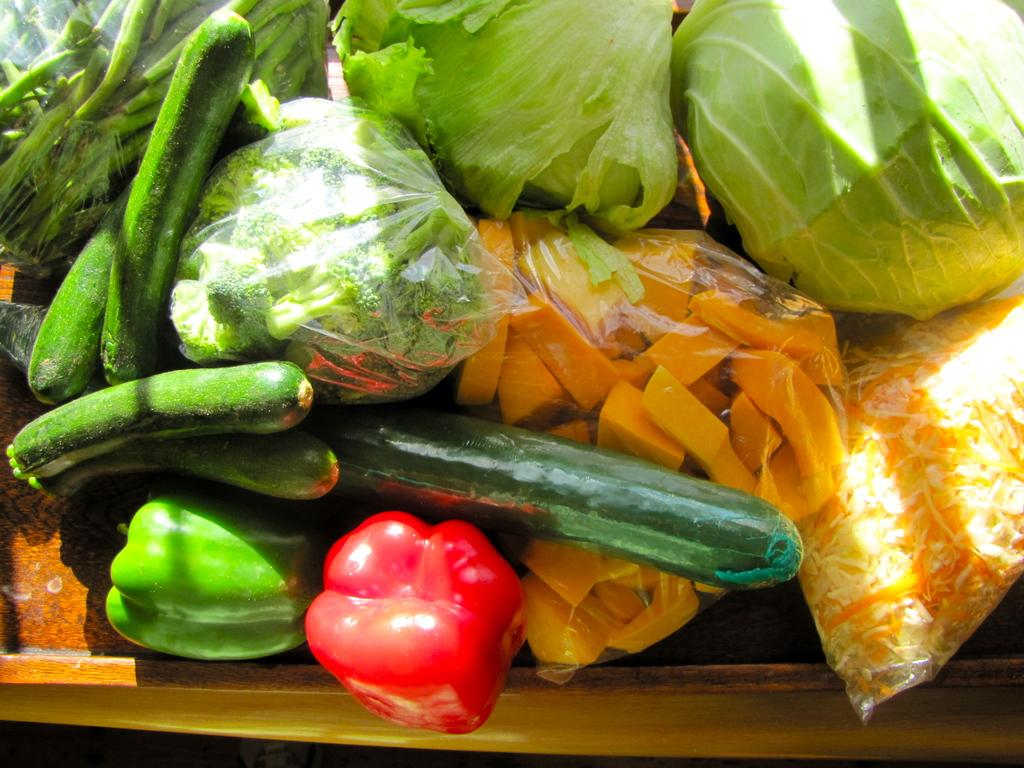What is located at the bottom of the image? There is a table at the bottom of the image. What is placed on the table? There are vegetables on the table. What type of quiver is being used during the meeting in the image? There is no meeting or quiver present in the image; it only features a table with vegetables on it. 